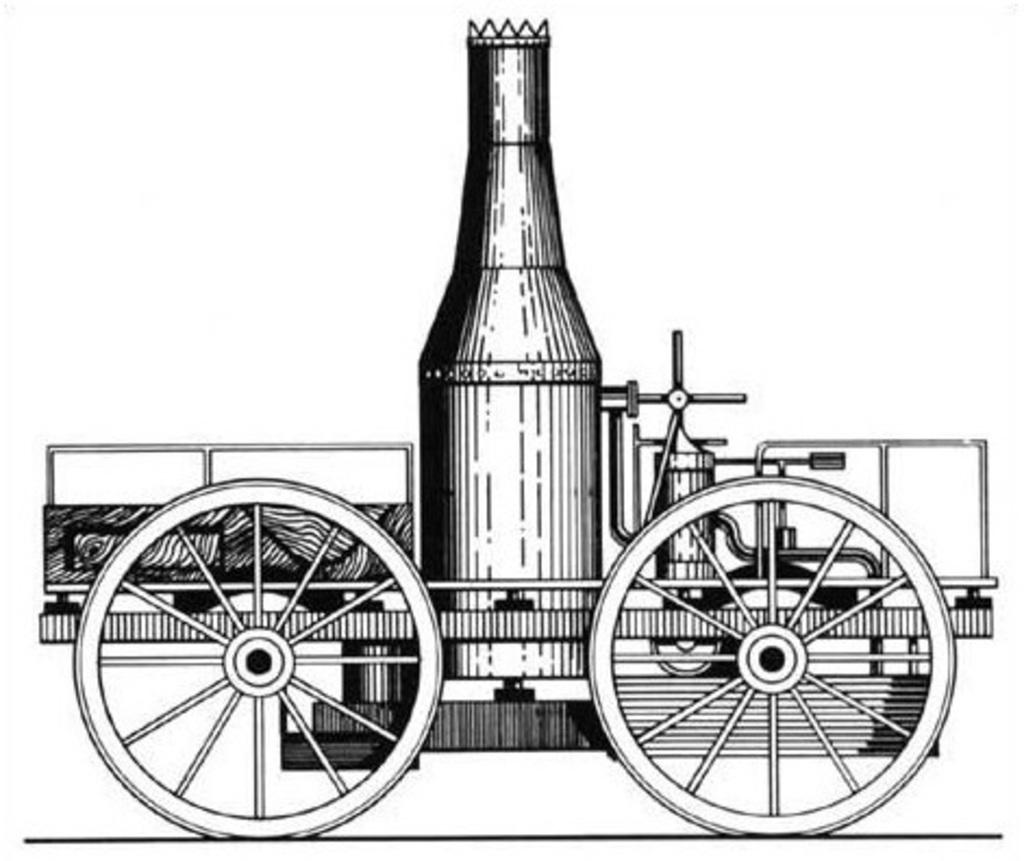What is the main subject of the image? The main subject of the image is a painting. What does the painting depict? The painting depicts a cart-like structure vehicle. What type of noise can be heard coming from the cart-like structure vehicle in the image? There is no sound present in the image, as it is a painting of a cart-like structure vehicle. Is the cart-like structure vehicle expanding in the image? The image is a static representation of the cart-like structure vehicle, so it is not expanding. 